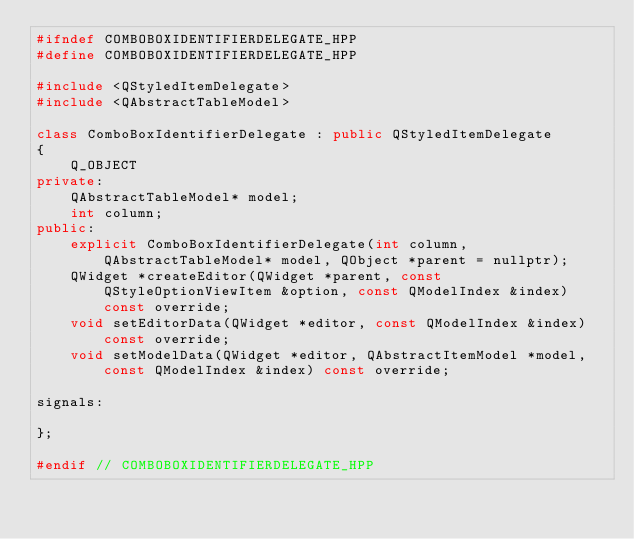Convert code to text. <code><loc_0><loc_0><loc_500><loc_500><_C++_>#ifndef COMBOBOXIDENTIFIERDELEGATE_HPP
#define COMBOBOXIDENTIFIERDELEGATE_HPP

#include <QStyledItemDelegate>
#include <QAbstractTableModel>

class ComboBoxIdentifierDelegate : public QStyledItemDelegate
{
	Q_OBJECT
private:
	QAbstractTableModel* model;
	int column;
public:
	explicit ComboBoxIdentifierDelegate(int column, QAbstractTableModel* model, QObject *parent = nullptr);
	QWidget *createEditor(QWidget *parent, const QStyleOptionViewItem &option, const QModelIndex &index) const override;
	void setEditorData(QWidget *editor, const QModelIndex &index) const override;
	void setModelData(QWidget *editor, QAbstractItemModel *model, const QModelIndex &index) const override;

signals:

};

#endif // COMBOBOXIDENTIFIERDELEGATE_HPP
</code> 